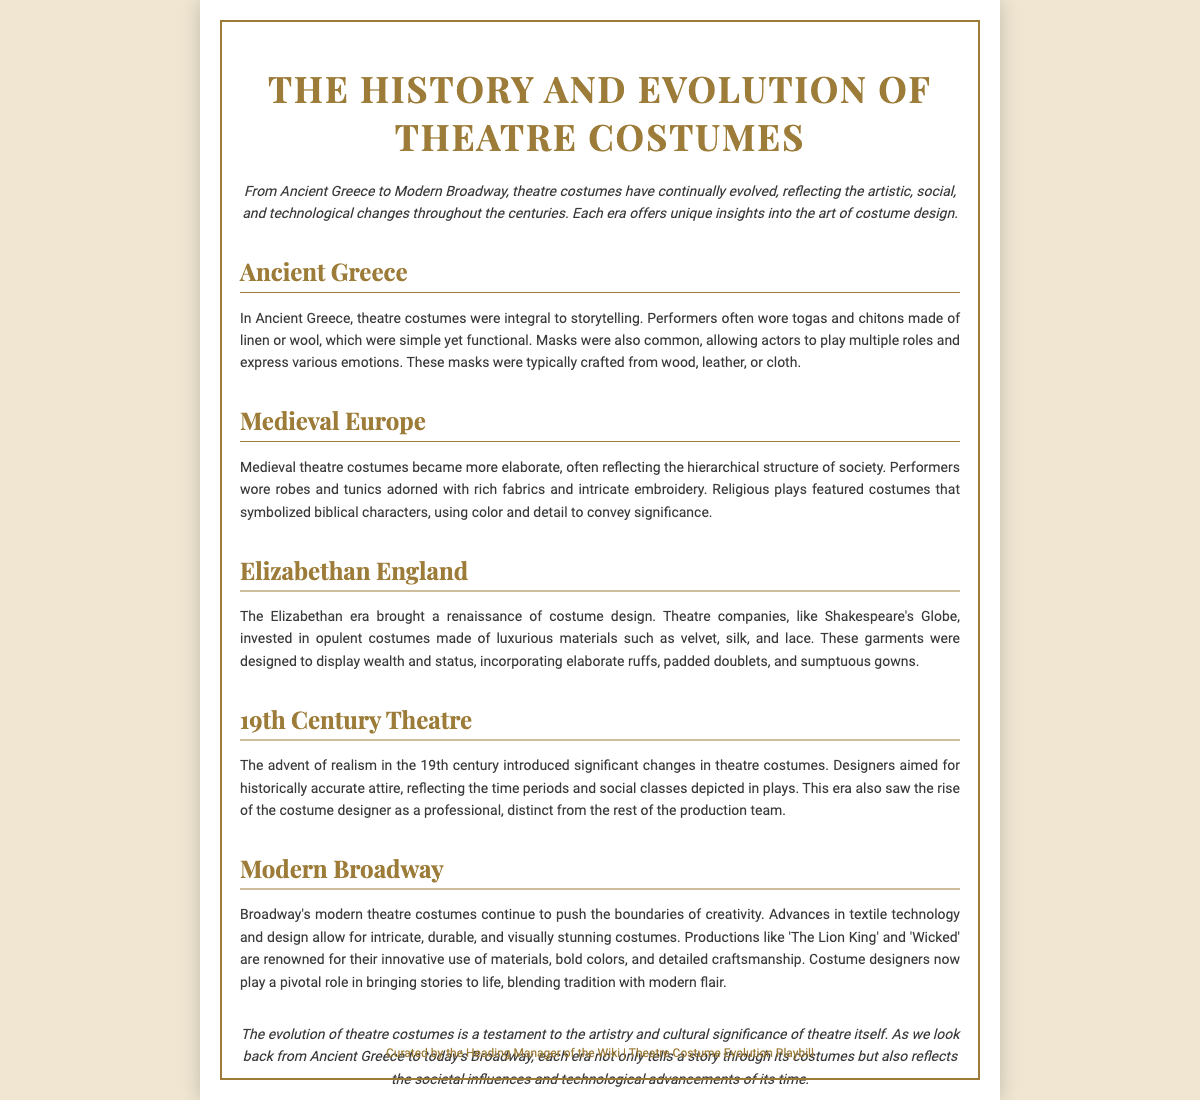What is the title of the Playbill? The title is prominently displayed at the top of the document, indicating the focus of the content.
Answer: The History and Evolution of Theatre Costumes What time period does the section "Ancient Greece" cover? The "Ancient Greece" section describes the costumes used during that historical period.
Answer: Ancient Greece What material was commonly used for masks in Ancient Greece? The document specifies the materials used for masks in the Ancient Greece section, highlighting their construction.
Answer: Wood, leather, or cloth Which theatre company's costumes are mentioned in the Elizabethan section? The Elizabethan section references a specific company known for its costume investment, indicating its importance in theatre history.
Answer: Shakespeare's Globe What significant change occurred in the 19th century regarding costume design? The 19th century section notes a key development in the role of costume designers, highlighting a shift in production collaboration.
Answer: Emergence of the costume designer as a professional Name one acclaimed modern Broadway production noted for its costumes. The modern Broadway section provides examples of productions recognized for their innovative costumes, showcasing contemporary creative achievements.
Answer: The Lion King What does the introduction suggest about the evolution of theatre costumes? The introduction encapsulates the overarching theme of the document, indicating historical progression in costume design.
Answer: Reflecting artistic, social, and technological changes Where is the conclusion located in the document? The conclusion is situated near the bottom of the Playbill, summarizing the overall insights about costume evolution.
Answer: At the end of the document What does the footer indicate about the content's curator? The footer provides information on who is responsible for the Playbill's curation, giving insight into its authority.
Answer: The Heading Manager of the Wiki 